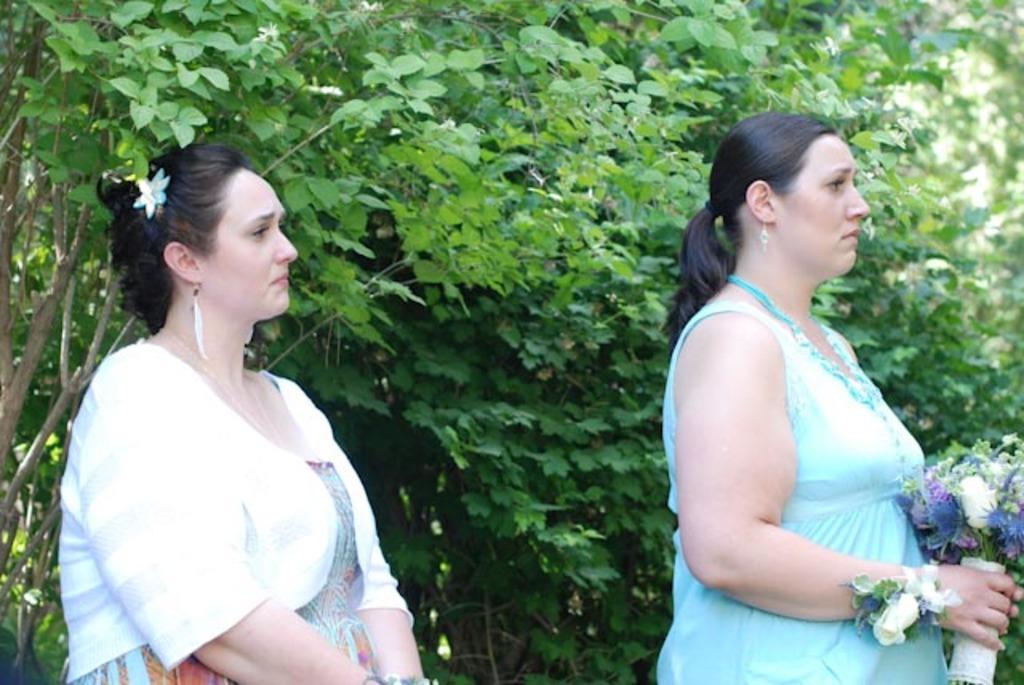Could you give a brief overview of what you see in this image? In this image I see 2 women in which this woman is wearing blue color dress and this woman is wearing white color dress and I see that this woman is holding a flower bouquet in her hands. In the background I see the plants. 